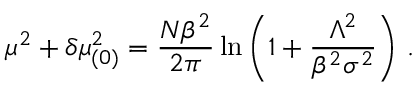Convert formula to latex. <formula><loc_0><loc_0><loc_500><loc_500>\mu ^ { 2 } + \delta \mu _ { ( 0 ) } ^ { 2 } = \frac { N \beta ^ { 2 } } { 2 \pi } \ln \left ( 1 + \frac { \Lambda ^ { 2 } } { \beta ^ { 2 } \sigma ^ { 2 } } \right ) \, .</formula> 